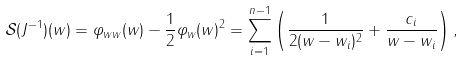Convert formula to latex. <formula><loc_0><loc_0><loc_500><loc_500>\mathcal { S } ( J ^ { - 1 } ) ( w ) = \varphi _ { w w } ( w ) - \frac { 1 } { 2 } \varphi _ { w } ( w ) ^ { 2 } = \sum _ { i = 1 } ^ { n - 1 } \left ( \frac { 1 } { 2 ( w - w _ { i } ) ^ { 2 } } + \frac { c _ { i } } { w - w _ { i } } \right ) ,</formula> 